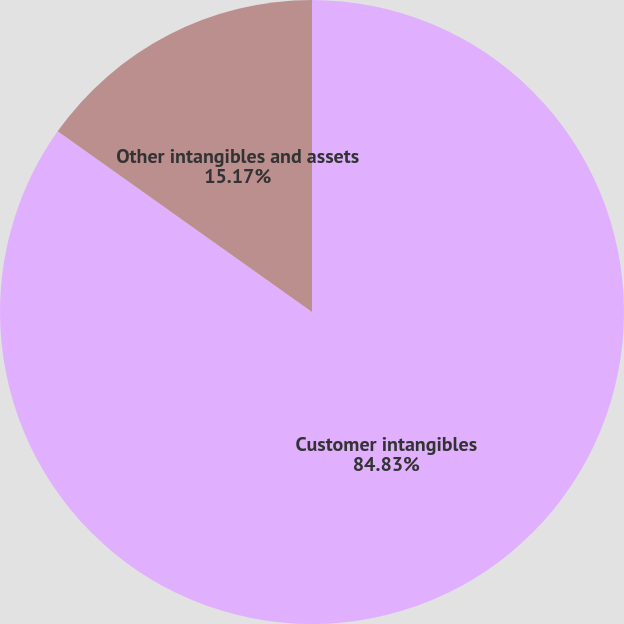<chart> <loc_0><loc_0><loc_500><loc_500><pie_chart><fcel>Customer intangibles<fcel>Other intangibles and assets<nl><fcel>84.83%<fcel>15.17%<nl></chart> 